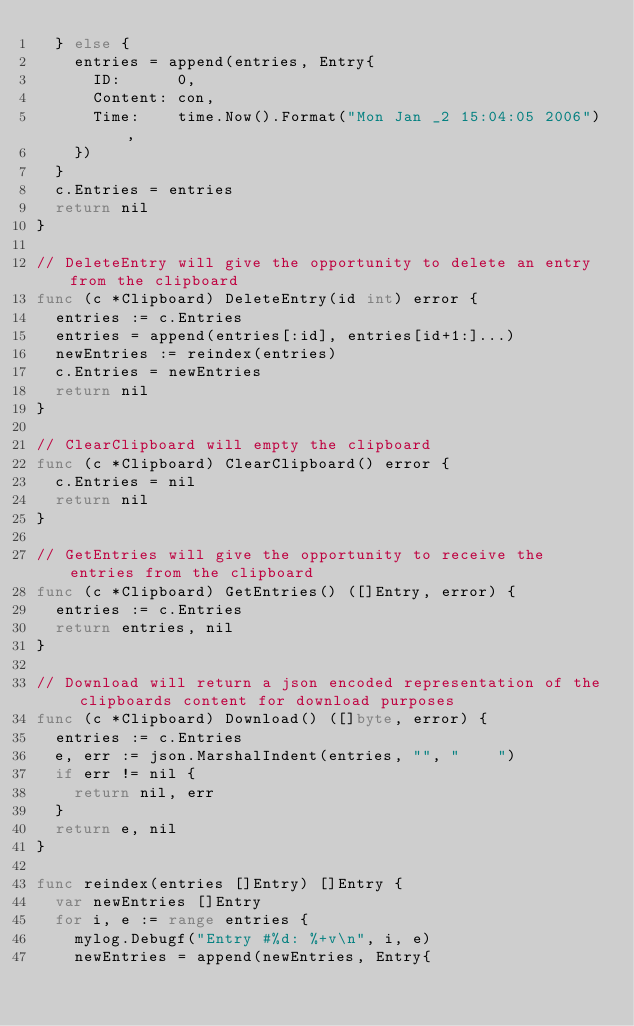Convert code to text. <code><loc_0><loc_0><loc_500><loc_500><_Go_>	} else {
		entries = append(entries, Entry{
			ID:      0,
			Content: con,
			Time:    time.Now().Format("Mon Jan _2 15:04:05 2006"),
		})
	}
	c.Entries = entries
	return nil
}

// DeleteEntry will give the opportunity to delete an entry from the clipboard
func (c *Clipboard) DeleteEntry(id int) error {
	entries := c.Entries
	entries = append(entries[:id], entries[id+1:]...)
	newEntries := reindex(entries)
	c.Entries = newEntries
	return nil
}

// ClearClipboard will empty the clipboard
func (c *Clipboard) ClearClipboard() error {
	c.Entries = nil
	return nil
}

// GetEntries will give the opportunity to receive the entries from the clipboard
func (c *Clipboard) GetEntries() ([]Entry, error) {
	entries := c.Entries
	return entries, nil
}

// Download will return a json encoded representation of the clipboards content for download purposes
func (c *Clipboard) Download() ([]byte, error) {
	entries := c.Entries
	e, err := json.MarshalIndent(entries, "", "    ")
	if err != nil {
		return nil, err
	}
	return e, nil
}

func reindex(entries []Entry) []Entry {
	var newEntries []Entry
	for i, e := range entries {
		mylog.Debugf("Entry #%d: %+v\n", i, e)
		newEntries = append(newEntries, Entry{</code> 